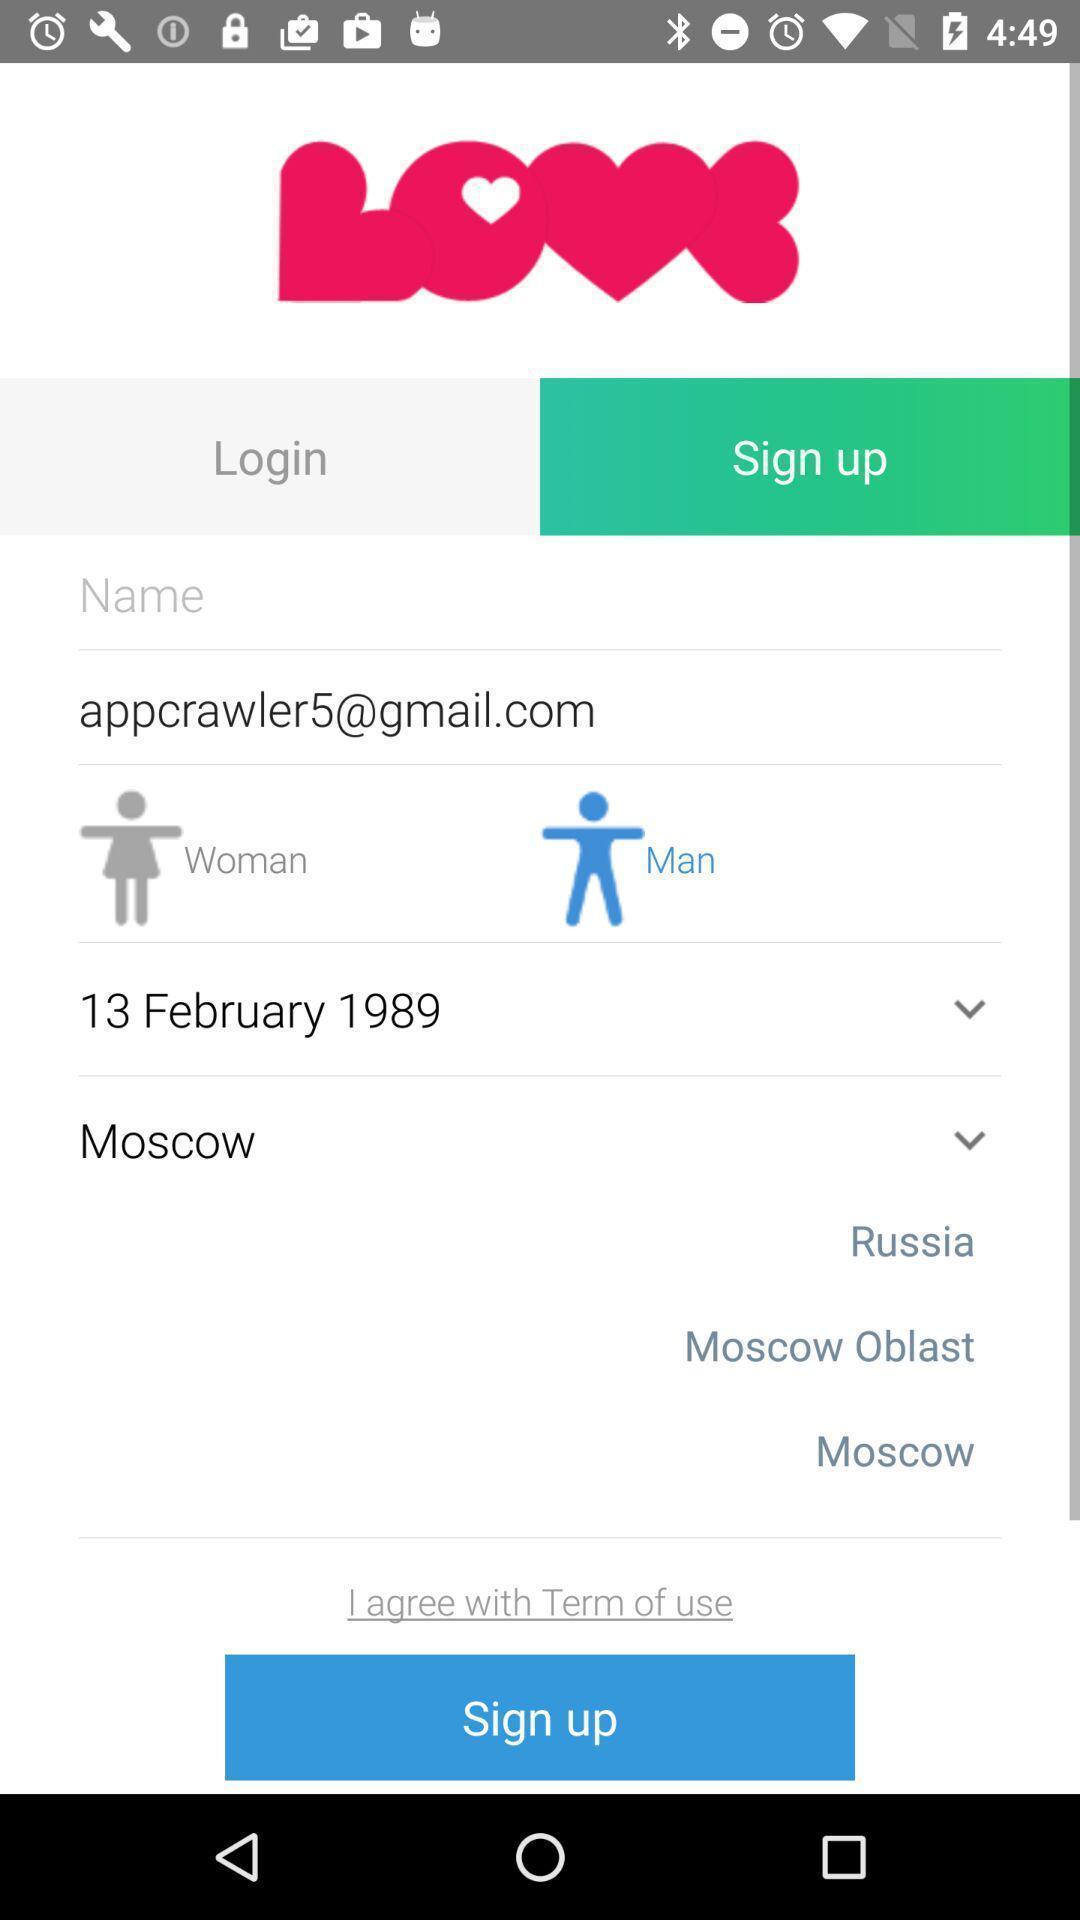Give me a summary of this screen capture. Sign up page. 